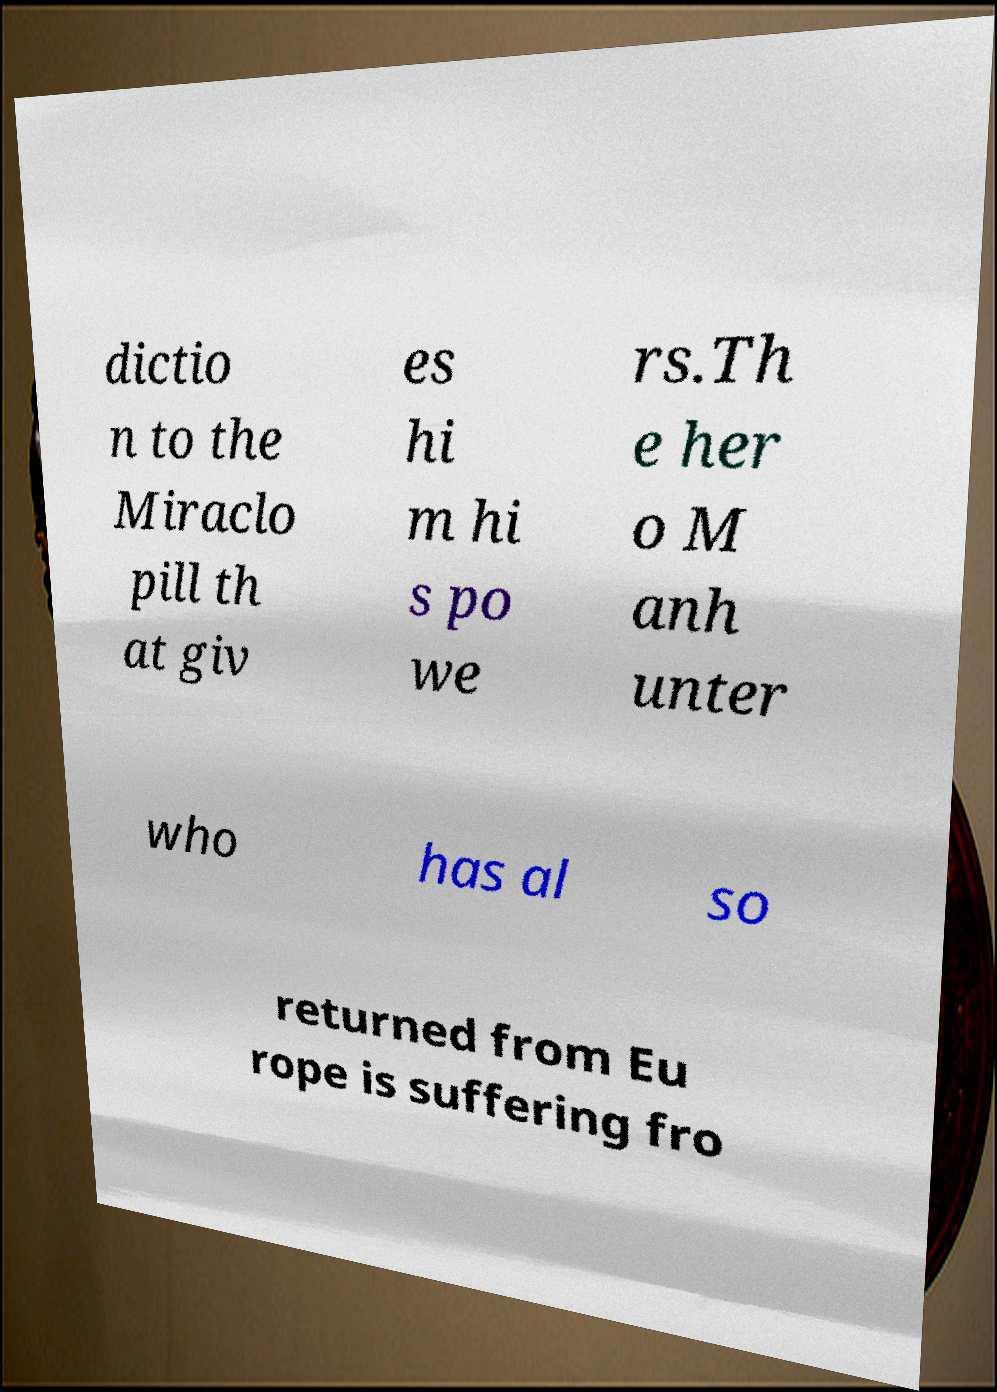Can you accurately transcribe the text from the provided image for me? dictio n to the Miraclo pill th at giv es hi m hi s po we rs.Th e her o M anh unter who has al so returned from Eu rope is suffering fro 